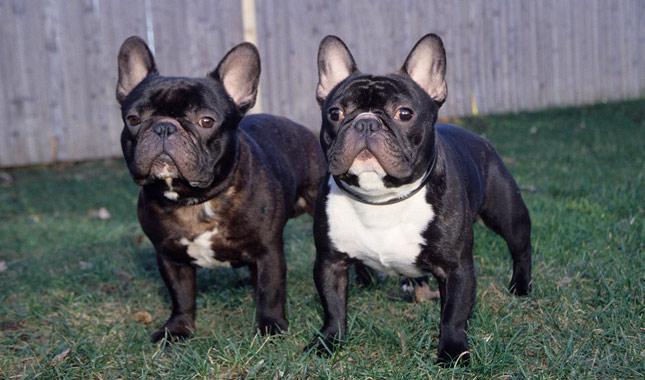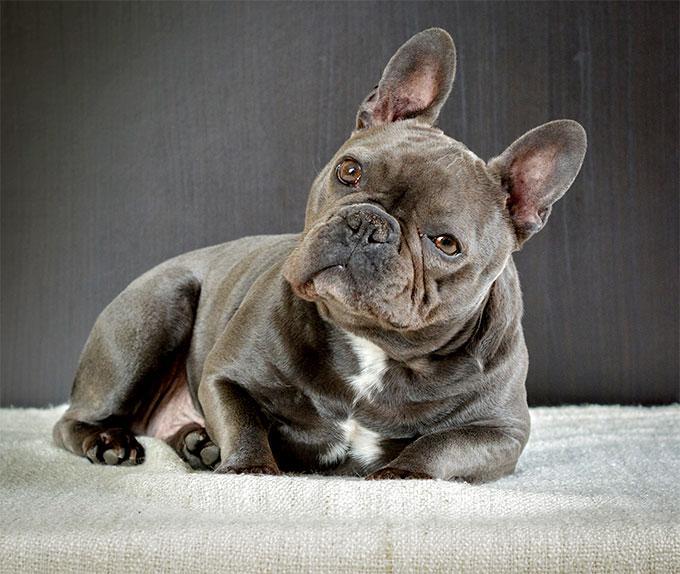The first image is the image on the left, the second image is the image on the right. Examine the images to the left and right. Is the description "Two dogs are posing together in the image on the left." accurate? Answer yes or no. Yes. The first image is the image on the left, the second image is the image on the right. Assess this claim about the two images: "The left image includes exactly twice as many dogs as the right image.". Correct or not? Answer yes or no. Yes. 